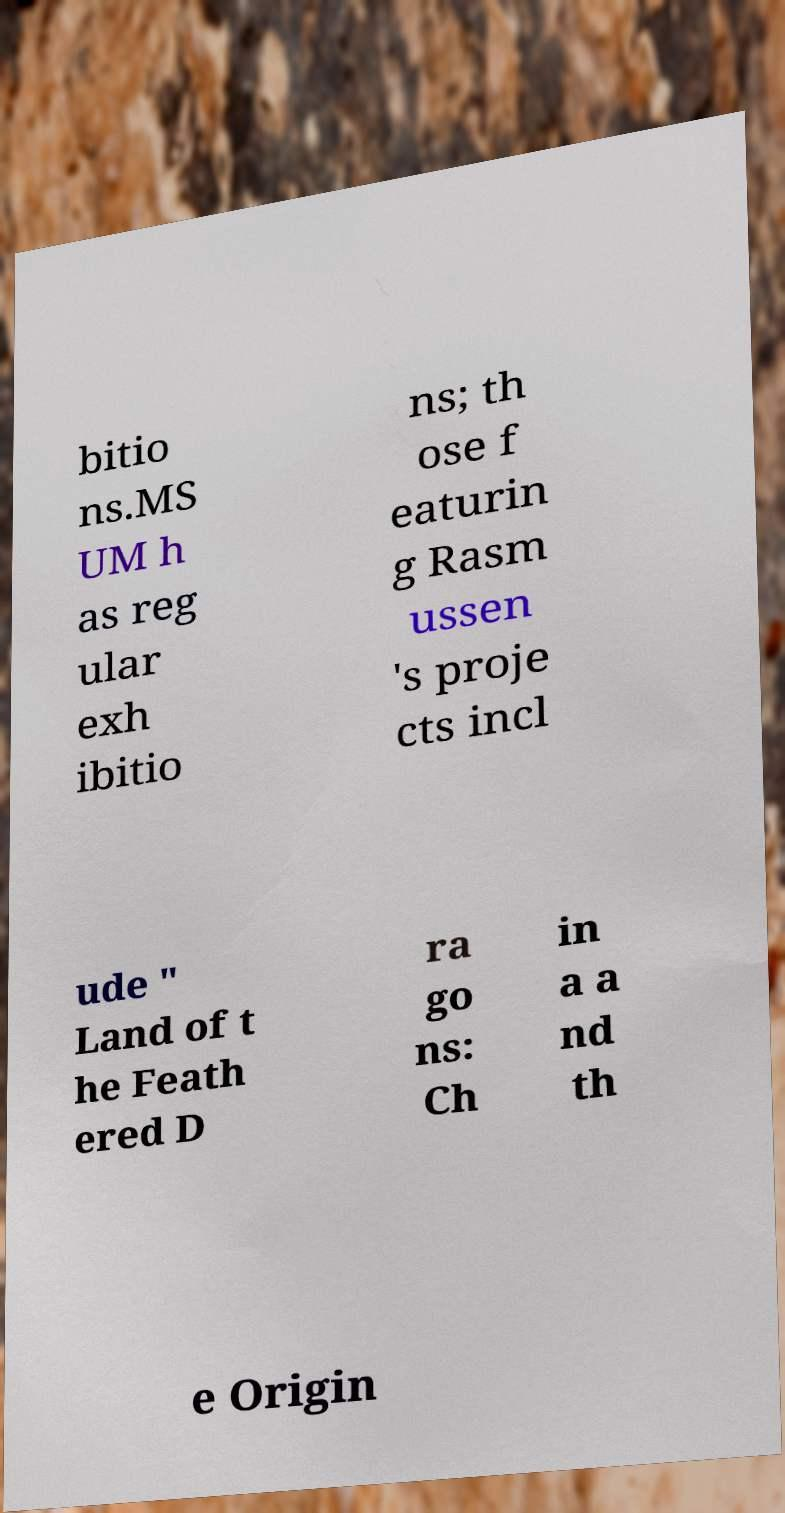Can you read and provide the text displayed in the image?This photo seems to have some interesting text. Can you extract and type it out for me? bitio ns.MS UM h as reg ular exh ibitio ns; th ose f eaturin g Rasm ussen 's proje cts incl ude " Land of t he Feath ered D ra go ns: Ch in a a nd th e Origin 